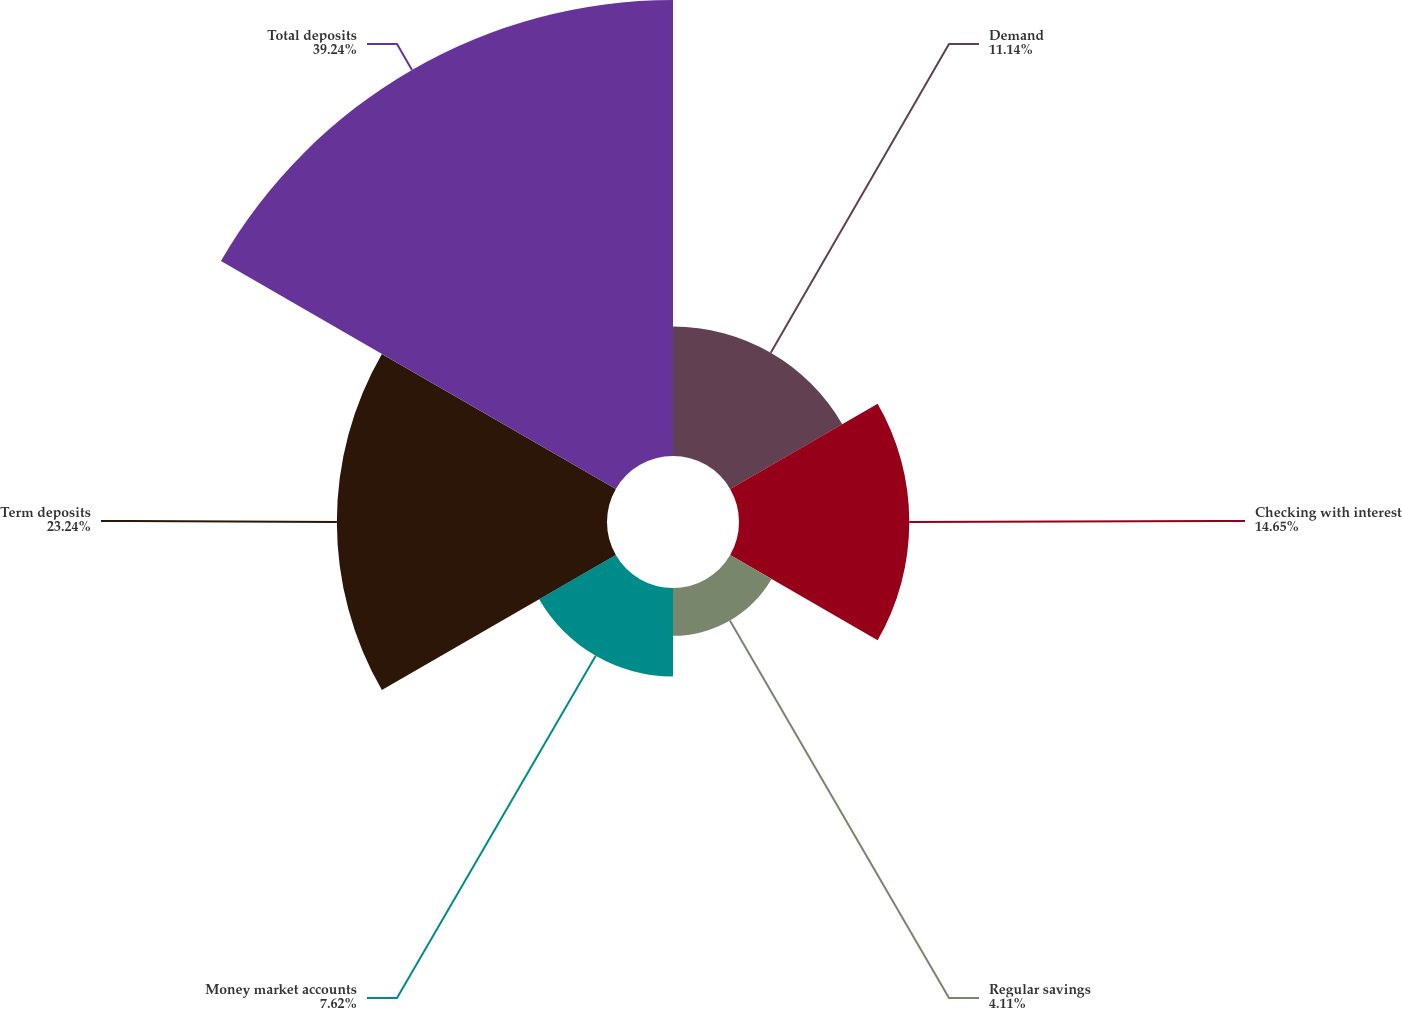Convert chart. <chart><loc_0><loc_0><loc_500><loc_500><pie_chart><fcel>Demand<fcel>Checking with interest<fcel>Regular savings<fcel>Money market accounts<fcel>Term deposits<fcel>Total deposits<nl><fcel>11.14%<fcel>14.65%<fcel>4.11%<fcel>7.62%<fcel>23.24%<fcel>39.23%<nl></chart> 